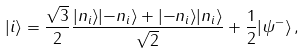Convert formula to latex. <formula><loc_0><loc_0><loc_500><loc_500>| i \rangle = \frac { \sqrt { 3 } } { 2 } \frac { | n _ { i } \rangle | { - } n _ { i } \rangle + | { - } n _ { i } \rangle | n _ { i } \rangle } { \sqrt { 2 } } + \frac { 1 } { 2 } | \psi ^ { - } \rangle \, ,</formula> 